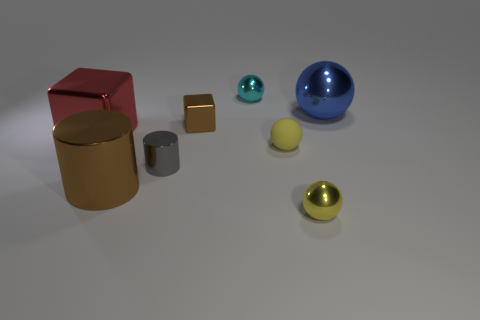There is a metal thing that is both in front of the big red cube and right of the tiny cyan object; what size is it?
Give a very brief answer. Small. What number of other tiny things have the same color as the tiny rubber thing?
Ensure brevity in your answer.  1. What material is the object that is the same color as the tiny matte sphere?
Provide a short and direct response. Metal. What is the tiny gray cylinder made of?
Make the answer very short. Metal. Is the material of the blue sphere that is right of the tiny cyan ball the same as the small cyan object?
Make the answer very short. Yes. There is a brown object in front of the tiny matte thing; what shape is it?
Your response must be concise. Cylinder. There is another yellow ball that is the same size as the yellow metallic sphere; what is it made of?
Provide a succinct answer. Rubber. How many objects are either objects that are right of the small cube or balls that are behind the big blue ball?
Offer a terse response. 4. What is the size of the red thing that is made of the same material as the large blue object?
Your answer should be compact. Large. How many matte objects are either large objects or blue spheres?
Provide a succinct answer. 0. 